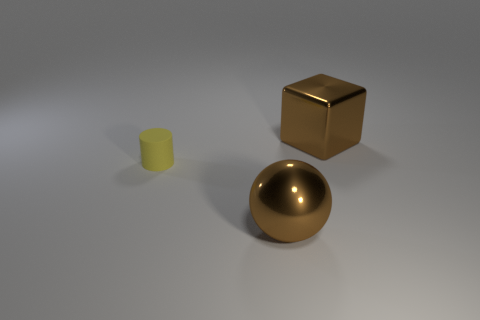Add 3 brown shiny things. How many objects exist? 6 Subtract all green cubes. How many cyan balls are left? 0 Subtract all cylinders. How many objects are left? 2 Subtract 1 spheres. How many spheres are left? 0 Subtract all blue balls. Subtract all red cylinders. How many balls are left? 1 Subtract all tiny red things. Subtract all small yellow matte cylinders. How many objects are left? 2 Add 3 large brown blocks. How many large brown blocks are left? 4 Add 2 blocks. How many blocks exist? 3 Subtract 0 green cylinders. How many objects are left? 3 